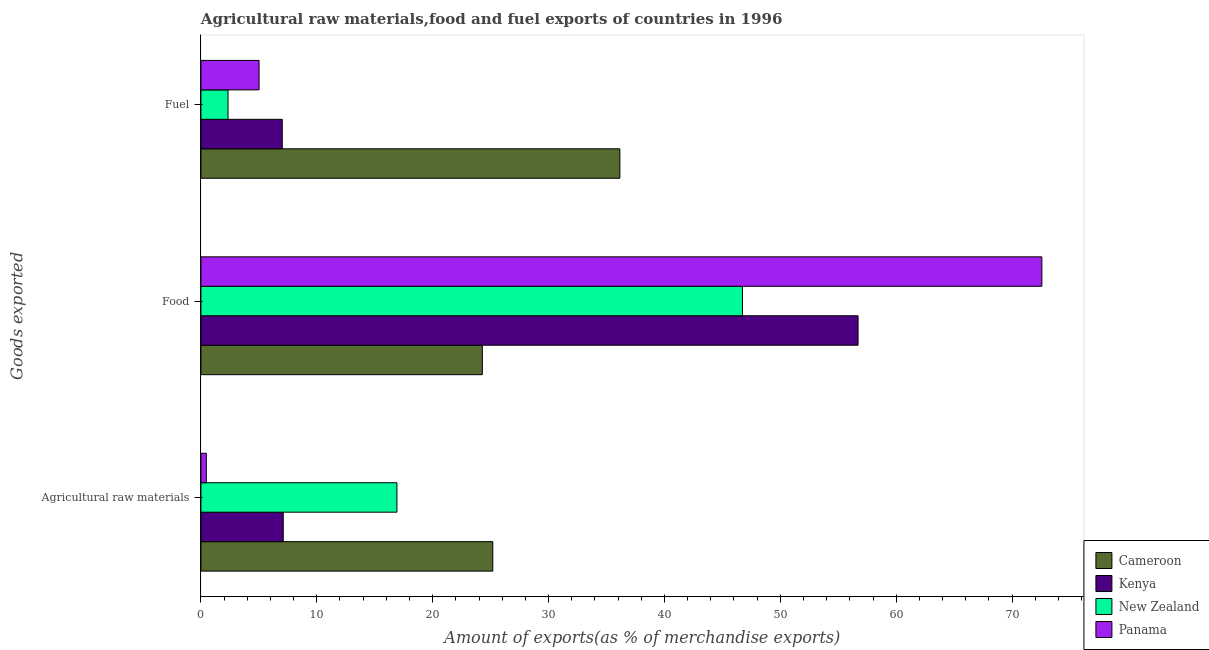How many different coloured bars are there?
Offer a very short reply. 4. Are the number of bars per tick equal to the number of legend labels?
Make the answer very short. Yes. Are the number of bars on each tick of the Y-axis equal?
Give a very brief answer. Yes. How many bars are there on the 1st tick from the top?
Keep it short and to the point. 4. How many bars are there on the 2nd tick from the bottom?
Offer a very short reply. 4. What is the label of the 1st group of bars from the top?
Offer a terse response. Fuel. What is the percentage of fuel exports in Kenya?
Provide a short and direct response. 7.02. Across all countries, what is the maximum percentage of food exports?
Make the answer very short. 72.57. Across all countries, what is the minimum percentage of raw materials exports?
Offer a very short reply. 0.47. In which country was the percentage of food exports maximum?
Your answer should be compact. Panama. In which country was the percentage of raw materials exports minimum?
Your response must be concise. Panama. What is the total percentage of food exports in the graph?
Offer a terse response. 200.3. What is the difference between the percentage of raw materials exports in Panama and that in Kenya?
Offer a terse response. -6.64. What is the difference between the percentage of fuel exports in Kenya and the percentage of raw materials exports in Panama?
Offer a terse response. 6.55. What is the average percentage of raw materials exports per country?
Provide a succinct answer. 12.42. What is the difference between the percentage of food exports and percentage of raw materials exports in New Zealand?
Ensure brevity in your answer.  29.82. What is the ratio of the percentage of fuel exports in Panama to that in Cameroon?
Ensure brevity in your answer.  0.14. What is the difference between the highest and the second highest percentage of food exports?
Keep it short and to the point. 15.86. What is the difference between the highest and the lowest percentage of raw materials exports?
Keep it short and to the point. 24.72. In how many countries, is the percentage of food exports greater than the average percentage of food exports taken over all countries?
Provide a succinct answer. 2. What does the 2nd bar from the top in Agricultural raw materials represents?
Your answer should be compact. New Zealand. What does the 2nd bar from the bottom in Food represents?
Offer a terse response. Kenya. Are all the bars in the graph horizontal?
Provide a short and direct response. Yes. Are the values on the major ticks of X-axis written in scientific E-notation?
Provide a succinct answer. No. Does the graph contain any zero values?
Keep it short and to the point. No. Does the graph contain grids?
Offer a very short reply. No. How are the legend labels stacked?
Offer a terse response. Vertical. What is the title of the graph?
Keep it short and to the point. Agricultural raw materials,food and fuel exports of countries in 1996. Does "Comoros" appear as one of the legend labels in the graph?
Make the answer very short. No. What is the label or title of the X-axis?
Give a very brief answer. Amount of exports(as % of merchandise exports). What is the label or title of the Y-axis?
Ensure brevity in your answer.  Goods exported. What is the Amount of exports(as % of merchandise exports) of Cameroon in Agricultural raw materials?
Your answer should be compact. 25.19. What is the Amount of exports(as % of merchandise exports) of Kenya in Agricultural raw materials?
Offer a terse response. 7.11. What is the Amount of exports(as % of merchandise exports) of New Zealand in Agricultural raw materials?
Offer a very short reply. 16.92. What is the Amount of exports(as % of merchandise exports) in Panama in Agricultural raw materials?
Your answer should be compact. 0.47. What is the Amount of exports(as % of merchandise exports) in Cameroon in Food?
Your response must be concise. 24.29. What is the Amount of exports(as % of merchandise exports) of Kenya in Food?
Give a very brief answer. 56.71. What is the Amount of exports(as % of merchandise exports) of New Zealand in Food?
Ensure brevity in your answer.  46.73. What is the Amount of exports(as % of merchandise exports) of Panama in Food?
Ensure brevity in your answer.  72.57. What is the Amount of exports(as % of merchandise exports) of Cameroon in Fuel?
Keep it short and to the point. 36.15. What is the Amount of exports(as % of merchandise exports) of Kenya in Fuel?
Ensure brevity in your answer.  7.02. What is the Amount of exports(as % of merchandise exports) of New Zealand in Fuel?
Your answer should be very brief. 2.34. What is the Amount of exports(as % of merchandise exports) in Panama in Fuel?
Your response must be concise. 5.02. Across all Goods exported, what is the maximum Amount of exports(as % of merchandise exports) of Cameroon?
Make the answer very short. 36.15. Across all Goods exported, what is the maximum Amount of exports(as % of merchandise exports) of Kenya?
Keep it short and to the point. 56.71. Across all Goods exported, what is the maximum Amount of exports(as % of merchandise exports) in New Zealand?
Give a very brief answer. 46.73. Across all Goods exported, what is the maximum Amount of exports(as % of merchandise exports) of Panama?
Offer a terse response. 72.57. Across all Goods exported, what is the minimum Amount of exports(as % of merchandise exports) of Cameroon?
Provide a short and direct response. 24.29. Across all Goods exported, what is the minimum Amount of exports(as % of merchandise exports) in Kenya?
Provide a short and direct response. 7.02. Across all Goods exported, what is the minimum Amount of exports(as % of merchandise exports) of New Zealand?
Offer a terse response. 2.34. Across all Goods exported, what is the minimum Amount of exports(as % of merchandise exports) in Panama?
Offer a terse response. 0.47. What is the total Amount of exports(as % of merchandise exports) in Cameroon in the graph?
Offer a terse response. 85.63. What is the total Amount of exports(as % of merchandise exports) of Kenya in the graph?
Provide a short and direct response. 70.84. What is the total Amount of exports(as % of merchandise exports) in New Zealand in the graph?
Keep it short and to the point. 65.99. What is the total Amount of exports(as % of merchandise exports) of Panama in the graph?
Keep it short and to the point. 78.06. What is the difference between the Amount of exports(as % of merchandise exports) of Cameroon in Agricultural raw materials and that in Food?
Provide a succinct answer. 0.9. What is the difference between the Amount of exports(as % of merchandise exports) of Kenya in Agricultural raw materials and that in Food?
Make the answer very short. -49.6. What is the difference between the Amount of exports(as % of merchandise exports) of New Zealand in Agricultural raw materials and that in Food?
Your answer should be compact. -29.82. What is the difference between the Amount of exports(as % of merchandise exports) of Panama in Agricultural raw materials and that in Food?
Ensure brevity in your answer.  -72.1. What is the difference between the Amount of exports(as % of merchandise exports) of Cameroon in Agricultural raw materials and that in Fuel?
Your answer should be compact. -10.96. What is the difference between the Amount of exports(as % of merchandise exports) in Kenya in Agricultural raw materials and that in Fuel?
Your response must be concise. 0.09. What is the difference between the Amount of exports(as % of merchandise exports) of New Zealand in Agricultural raw materials and that in Fuel?
Provide a short and direct response. 14.58. What is the difference between the Amount of exports(as % of merchandise exports) in Panama in Agricultural raw materials and that in Fuel?
Your answer should be very brief. -4.55. What is the difference between the Amount of exports(as % of merchandise exports) in Cameroon in Food and that in Fuel?
Your answer should be compact. -11.87. What is the difference between the Amount of exports(as % of merchandise exports) of Kenya in Food and that in Fuel?
Give a very brief answer. 49.69. What is the difference between the Amount of exports(as % of merchandise exports) in New Zealand in Food and that in Fuel?
Offer a terse response. 44.39. What is the difference between the Amount of exports(as % of merchandise exports) in Panama in Food and that in Fuel?
Provide a succinct answer. 67.55. What is the difference between the Amount of exports(as % of merchandise exports) in Cameroon in Agricultural raw materials and the Amount of exports(as % of merchandise exports) in Kenya in Food?
Give a very brief answer. -31.52. What is the difference between the Amount of exports(as % of merchandise exports) of Cameroon in Agricultural raw materials and the Amount of exports(as % of merchandise exports) of New Zealand in Food?
Ensure brevity in your answer.  -21.55. What is the difference between the Amount of exports(as % of merchandise exports) of Cameroon in Agricultural raw materials and the Amount of exports(as % of merchandise exports) of Panama in Food?
Offer a terse response. -47.38. What is the difference between the Amount of exports(as % of merchandise exports) in Kenya in Agricultural raw materials and the Amount of exports(as % of merchandise exports) in New Zealand in Food?
Provide a succinct answer. -39.63. What is the difference between the Amount of exports(as % of merchandise exports) of Kenya in Agricultural raw materials and the Amount of exports(as % of merchandise exports) of Panama in Food?
Your answer should be compact. -65.46. What is the difference between the Amount of exports(as % of merchandise exports) in New Zealand in Agricultural raw materials and the Amount of exports(as % of merchandise exports) in Panama in Food?
Give a very brief answer. -55.65. What is the difference between the Amount of exports(as % of merchandise exports) of Cameroon in Agricultural raw materials and the Amount of exports(as % of merchandise exports) of Kenya in Fuel?
Offer a terse response. 18.17. What is the difference between the Amount of exports(as % of merchandise exports) of Cameroon in Agricultural raw materials and the Amount of exports(as % of merchandise exports) of New Zealand in Fuel?
Provide a short and direct response. 22.85. What is the difference between the Amount of exports(as % of merchandise exports) of Cameroon in Agricultural raw materials and the Amount of exports(as % of merchandise exports) of Panama in Fuel?
Provide a succinct answer. 20.17. What is the difference between the Amount of exports(as % of merchandise exports) in Kenya in Agricultural raw materials and the Amount of exports(as % of merchandise exports) in New Zealand in Fuel?
Your answer should be compact. 4.77. What is the difference between the Amount of exports(as % of merchandise exports) in Kenya in Agricultural raw materials and the Amount of exports(as % of merchandise exports) in Panama in Fuel?
Provide a succinct answer. 2.09. What is the difference between the Amount of exports(as % of merchandise exports) in New Zealand in Agricultural raw materials and the Amount of exports(as % of merchandise exports) in Panama in Fuel?
Provide a succinct answer. 11.9. What is the difference between the Amount of exports(as % of merchandise exports) of Cameroon in Food and the Amount of exports(as % of merchandise exports) of Kenya in Fuel?
Provide a succinct answer. 17.27. What is the difference between the Amount of exports(as % of merchandise exports) in Cameroon in Food and the Amount of exports(as % of merchandise exports) in New Zealand in Fuel?
Make the answer very short. 21.95. What is the difference between the Amount of exports(as % of merchandise exports) in Cameroon in Food and the Amount of exports(as % of merchandise exports) in Panama in Fuel?
Provide a succinct answer. 19.27. What is the difference between the Amount of exports(as % of merchandise exports) in Kenya in Food and the Amount of exports(as % of merchandise exports) in New Zealand in Fuel?
Provide a short and direct response. 54.37. What is the difference between the Amount of exports(as % of merchandise exports) in Kenya in Food and the Amount of exports(as % of merchandise exports) in Panama in Fuel?
Your answer should be compact. 51.69. What is the difference between the Amount of exports(as % of merchandise exports) of New Zealand in Food and the Amount of exports(as % of merchandise exports) of Panama in Fuel?
Ensure brevity in your answer.  41.72. What is the average Amount of exports(as % of merchandise exports) in Cameroon per Goods exported?
Give a very brief answer. 28.54. What is the average Amount of exports(as % of merchandise exports) of Kenya per Goods exported?
Provide a short and direct response. 23.61. What is the average Amount of exports(as % of merchandise exports) of New Zealand per Goods exported?
Offer a terse response. 22. What is the average Amount of exports(as % of merchandise exports) of Panama per Goods exported?
Give a very brief answer. 26.02. What is the difference between the Amount of exports(as % of merchandise exports) of Cameroon and Amount of exports(as % of merchandise exports) of Kenya in Agricultural raw materials?
Offer a terse response. 18.08. What is the difference between the Amount of exports(as % of merchandise exports) of Cameroon and Amount of exports(as % of merchandise exports) of New Zealand in Agricultural raw materials?
Offer a very short reply. 8.27. What is the difference between the Amount of exports(as % of merchandise exports) of Cameroon and Amount of exports(as % of merchandise exports) of Panama in Agricultural raw materials?
Ensure brevity in your answer.  24.72. What is the difference between the Amount of exports(as % of merchandise exports) of Kenya and Amount of exports(as % of merchandise exports) of New Zealand in Agricultural raw materials?
Make the answer very short. -9.81. What is the difference between the Amount of exports(as % of merchandise exports) in Kenya and Amount of exports(as % of merchandise exports) in Panama in Agricultural raw materials?
Provide a short and direct response. 6.64. What is the difference between the Amount of exports(as % of merchandise exports) of New Zealand and Amount of exports(as % of merchandise exports) of Panama in Agricultural raw materials?
Offer a terse response. 16.45. What is the difference between the Amount of exports(as % of merchandise exports) of Cameroon and Amount of exports(as % of merchandise exports) of Kenya in Food?
Your response must be concise. -32.42. What is the difference between the Amount of exports(as % of merchandise exports) in Cameroon and Amount of exports(as % of merchandise exports) in New Zealand in Food?
Make the answer very short. -22.45. What is the difference between the Amount of exports(as % of merchandise exports) in Cameroon and Amount of exports(as % of merchandise exports) in Panama in Food?
Offer a very short reply. -48.28. What is the difference between the Amount of exports(as % of merchandise exports) in Kenya and Amount of exports(as % of merchandise exports) in New Zealand in Food?
Make the answer very short. 9.98. What is the difference between the Amount of exports(as % of merchandise exports) of Kenya and Amount of exports(as % of merchandise exports) of Panama in Food?
Your answer should be compact. -15.86. What is the difference between the Amount of exports(as % of merchandise exports) of New Zealand and Amount of exports(as % of merchandise exports) of Panama in Food?
Make the answer very short. -25.83. What is the difference between the Amount of exports(as % of merchandise exports) in Cameroon and Amount of exports(as % of merchandise exports) in Kenya in Fuel?
Give a very brief answer. 29.13. What is the difference between the Amount of exports(as % of merchandise exports) in Cameroon and Amount of exports(as % of merchandise exports) in New Zealand in Fuel?
Provide a succinct answer. 33.81. What is the difference between the Amount of exports(as % of merchandise exports) in Cameroon and Amount of exports(as % of merchandise exports) in Panama in Fuel?
Offer a very short reply. 31.13. What is the difference between the Amount of exports(as % of merchandise exports) of Kenya and Amount of exports(as % of merchandise exports) of New Zealand in Fuel?
Provide a short and direct response. 4.68. What is the difference between the Amount of exports(as % of merchandise exports) of New Zealand and Amount of exports(as % of merchandise exports) of Panama in Fuel?
Provide a succinct answer. -2.68. What is the ratio of the Amount of exports(as % of merchandise exports) in Cameroon in Agricultural raw materials to that in Food?
Your answer should be very brief. 1.04. What is the ratio of the Amount of exports(as % of merchandise exports) in Kenya in Agricultural raw materials to that in Food?
Provide a succinct answer. 0.13. What is the ratio of the Amount of exports(as % of merchandise exports) of New Zealand in Agricultural raw materials to that in Food?
Your response must be concise. 0.36. What is the ratio of the Amount of exports(as % of merchandise exports) in Panama in Agricultural raw materials to that in Food?
Offer a terse response. 0.01. What is the ratio of the Amount of exports(as % of merchandise exports) of Cameroon in Agricultural raw materials to that in Fuel?
Provide a short and direct response. 0.7. What is the ratio of the Amount of exports(as % of merchandise exports) of Kenya in Agricultural raw materials to that in Fuel?
Offer a very short reply. 1.01. What is the ratio of the Amount of exports(as % of merchandise exports) of New Zealand in Agricultural raw materials to that in Fuel?
Provide a succinct answer. 7.23. What is the ratio of the Amount of exports(as % of merchandise exports) of Panama in Agricultural raw materials to that in Fuel?
Offer a very short reply. 0.09. What is the ratio of the Amount of exports(as % of merchandise exports) in Cameroon in Food to that in Fuel?
Your response must be concise. 0.67. What is the ratio of the Amount of exports(as % of merchandise exports) of Kenya in Food to that in Fuel?
Keep it short and to the point. 8.08. What is the ratio of the Amount of exports(as % of merchandise exports) of New Zealand in Food to that in Fuel?
Ensure brevity in your answer.  19.97. What is the ratio of the Amount of exports(as % of merchandise exports) in Panama in Food to that in Fuel?
Provide a succinct answer. 14.46. What is the difference between the highest and the second highest Amount of exports(as % of merchandise exports) in Cameroon?
Ensure brevity in your answer.  10.96. What is the difference between the highest and the second highest Amount of exports(as % of merchandise exports) in Kenya?
Give a very brief answer. 49.6. What is the difference between the highest and the second highest Amount of exports(as % of merchandise exports) in New Zealand?
Keep it short and to the point. 29.82. What is the difference between the highest and the second highest Amount of exports(as % of merchandise exports) of Panama?
Your answer should be very brief. 67.55. What is the difference between the highest and the lowest Amount of exports(as % of merchandise exports) of Cameroon?
Your answer should be very brief. 11.87. What is the difference between the highest and the lowest Amount of exports(as % of merchandise exports) in Kenya?
Keep it short and to the point. 49.69. What is the difference between the highest and the lowest Amount of exports(as % of merchandise exports) of New Zealand?
Provide a succinct answer. 44.39. What is the difference between the highest and the lowest Amount of exports(as % of merchandise exports) in Panama?
Keep it short and to the point. 72.1. 